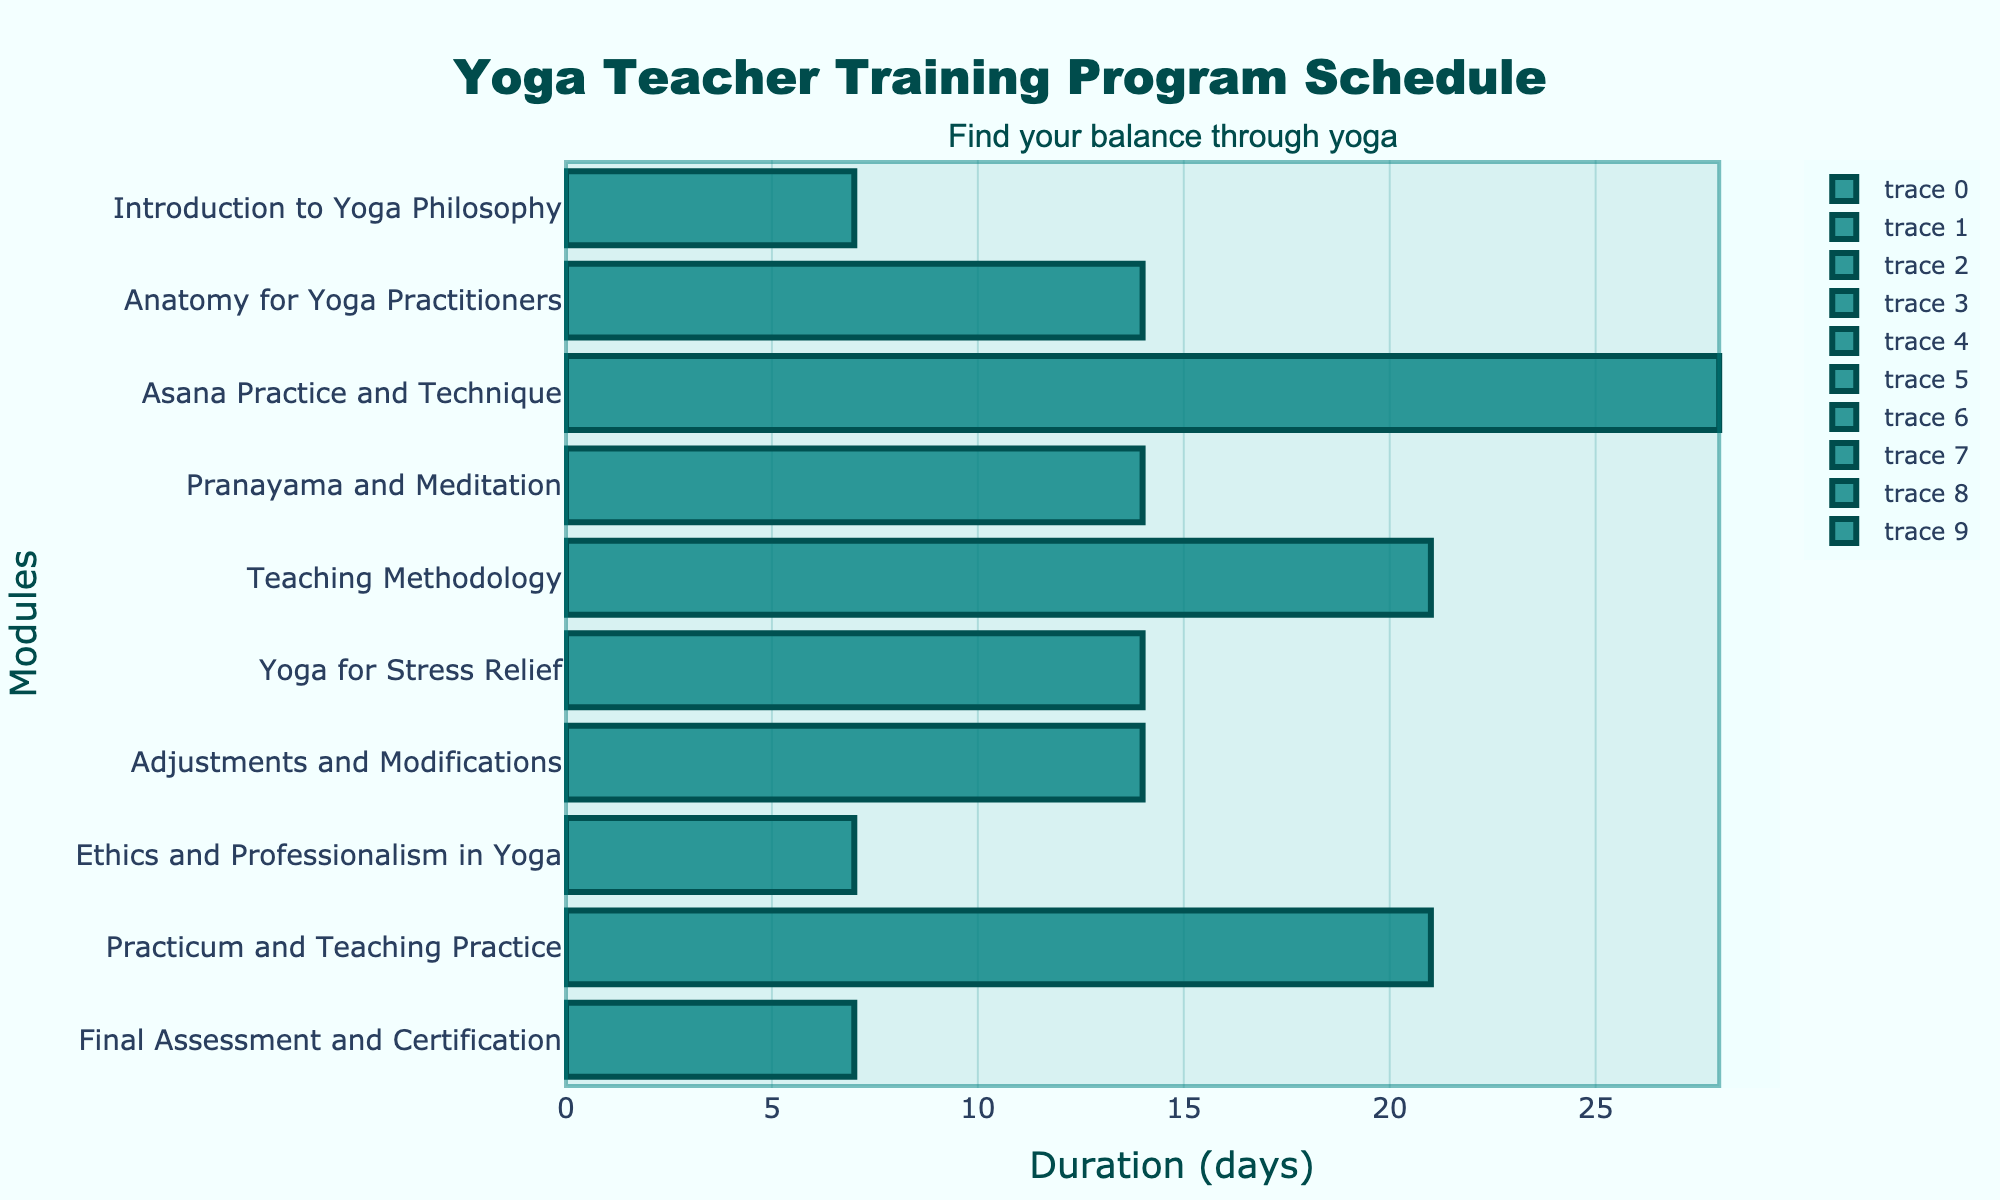What is the title of the Gantt chart? The title of a Gantt chart is usually found at the top of the figure and describes the main subject of the chart. In this Gantt chart, the title reads "Yoga Teacher Training Program Schedule."
Answer: Yoga Teacher Training Program Schedule How many modules are included in the Yoga Teacher Training Program? Count the number of horizontal bars or tasks listed on the y-axis. Each bar represents one module in the training program.
Answer: 10 What is the duration of the "Asana Practice and Technique" module? Look for the bar labeled "Asana Practice and Technique" and read the hover text or duration directly on the x-axis. The duration is the difference between the start and end dates plus one day.
Answer: 28 days Which module has the shortest duration, and how long is it? Compare the length of each bar (the duration) and find the shortest one. The shortest bar corresponds to the "Ethics and Professionalism in Yoga" module.
Answer: Ethics and Professionalism in Yoga, 7 days When does the "Pranayama and Meditation" module start and end? Find the bar labeled "Pranayama and Meditation" and read the start and end dates from the hover text or x-axis labels.
Answer: Starts on 2023-10-20, ends on 2023-11-02 How many days does the entire Yoga Teacher Training Program last? Identify the start date of the first module ("Introduction to Yoga Philosophy") and the end date of the last module ("Final Assessment and Certification"). Subtract the start date from the end date and add one day for full inclusion.
Answer: 147 days Which module directly follows "Teaching Methodology"? Identify "Teaching Methodology" on the y-axis and look at the next bar below it. The next module is "Yoga for Stress Relief."
Answer: Yoga for Stress Relief Which module ends right before "Adjustments and Modifications" begins? Identify the position of "Adjustments and Modifications" and look at the bar directly above it to find the preceding module. The module preceding it is "Yoga for Stress Relief."
Answer: Yoga for Stress Relief Compare the duration of "Teaching Methodology" and "Practicum and Teaching Practice." Which one is longer and by how many days? Locate both "Teaching Methodology" and "Practicum and Teaching Practice" on the y-axis. Compare their durations by subtracting one from the other. "Practicum and Teaching Practice" has a duration of 21 days, while "Teaching Methodology" lasts for 21 days; thus, they have the same duration.
Answer: Both are equal, 0 days What is the cumulative duration of the first three modules? Sum the durations of "Introduction to Yoga Philosophy," "Anatomy for Yoga Practitioners," and "Asana Practice and Technique." They last 7, 14, and 28 days respectively.
Answer: 49 days 